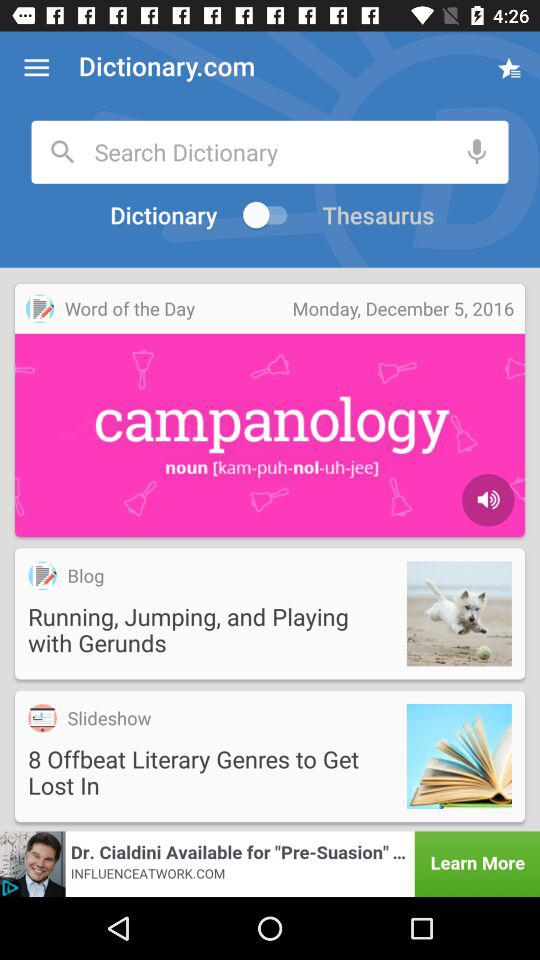What is the mentioned date? The mentioned date is Monday, December 5, 2016. 